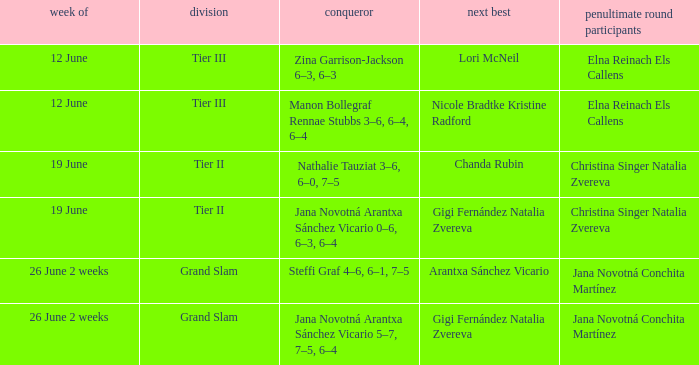In which week is the triumphant player listed as jana novotná arantxa sánchez vicario 5–7, 7–5, 6–4? 26 June 2 weeks. 